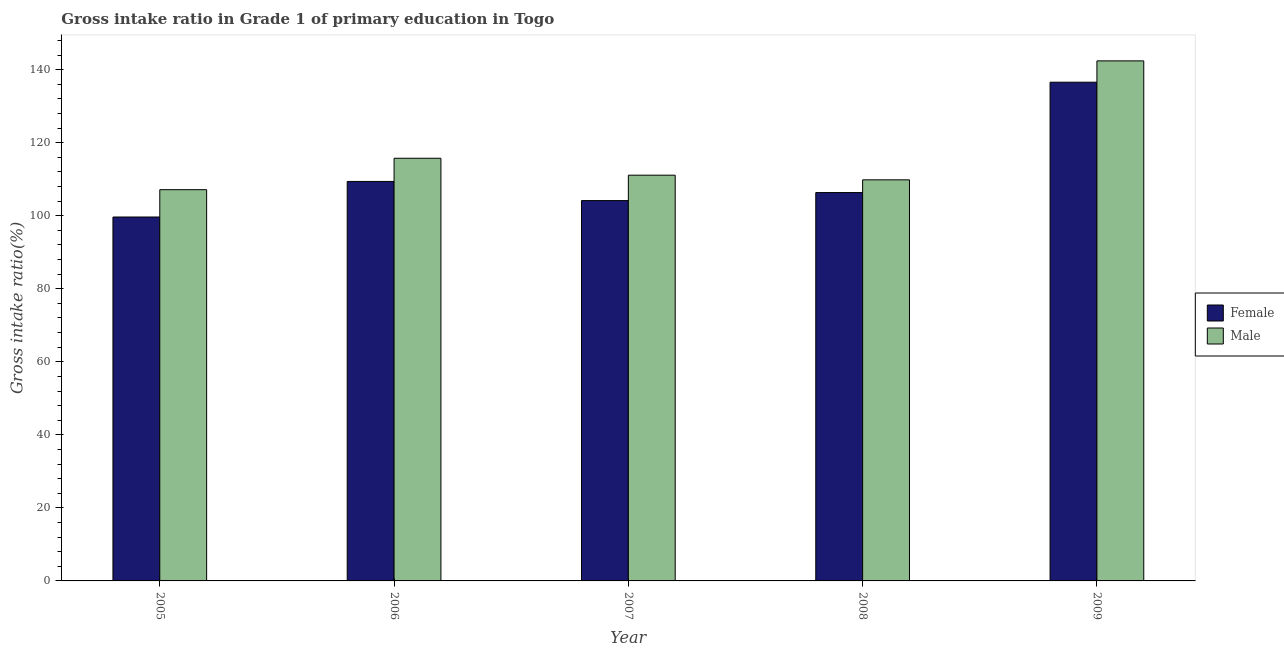How many groups of bars are there?
Make the answer very short. 5. How many bars are there on the 4th tick from the left?
Ensure brevity in your answer.  2. In how many cases, is the number of bars for a given year not equal to the number of legend labels?
Your response must be concise. 0. What is the gross intake ratio(male) in 2007?
Offer a terse response. 111.11. Across all years, what is the maximum gross intake ratio(female)?
Your answer should be very brief. 136.56. Across all years, what is the minimum gross intake ratio(female)?
Ensure brevity in your answer.  99.65. In which year was the gross intake ratio(female) minimum?
Provide a succinct answer. 2005. What is the total gross intake ratio(male) in the graph?
Give a very brief answer. 586.22. What is the difference between the gross intake ratio(male) in 2006 and that in 2007?
Give a very brief answer. 4.63. What is the difference between the gross intake ratio(female) in 2009 and the gross intake ratio(male) in 2006?
Offer a very short reply. 27.18. What is the average gross intake ratio(female) per year?
Offer a very short reply. 111.22. In how many years, is the gross intake ratio(male) greater than 96 %?
Ensure brevity in your answer.  5. What is the ratio of the gross intake ratio(female) in 2006 to that in 2007?
Provide a succinct answer. 1.05. Is the difference between the gross intake ratio(male) in 2007 and 2008 greater than the difference between the gross intake ratio(female) in 2007 and 2008?
Offer a very short reply. No. What is the difference between the highest and the second highest gross intake ratio(male)?
Your answer should be compact. 26.66. What is the difference between the highest and the lowest gross intake ratio(female)?
Your response must be concise. 36.91. Is the sum of the gross intake ratio(male) in 2007 and 2008 greater than the maximum gross intake ratio(female) across all years?
Ensure brevity in your answer.  Yes. What does the 1st bar from the left in 2009 represents?
Provide a short and direct response. Female. How many bars are there?
Offer a very short reply. 10. How many years are there in the graph?
Keep it short and to the point. 5. Does the graph contain any zero values?
Your answer should be compact. No. Does the graph contain grids?
Your answer should be very brief. No. Where does the legend appear in the graph?
Your answer should be very brief. Center right. How are the legend labels stacked?
Keep it short and to the point. Vertical. What is the title of the graph?
Provide a succinct answer. Gross intake ratio in Grade 1 of primary education in Togo. Does "Urban" appear as one of the legend labels in the graph?
Your response must be concise. No. What is the label or title of the Y-axis?
Provide a short and direct response. Gross intake ratio(%). What is the Gross intake ratio(%) in Female in 2005?
Keep it short and to the point. 99.65. What is the Gross intake ratio(%) in Male in 2005?
Provide a short and direct response. 107.14. What is the Gross intake ratio(%) in Female in 2006?
Provide a short and direct response. 109.39. What is the Gross intake ratio(%) of Male in 2006?
Your response must be concise. 115.74. What is the Gross intake ratio(%) in Female in 2007?
Offer a terse response. 104.15. What is the Gross intake ratio(%) in Male in 2007?
Make the answer very short. 111.11. What is the Gross intake ratio(%) of Female in 2008?
Your answer should be compact. 106.35. What is the Gross intake ratio(%) of Male in 2008?
Keep it short and to the point. 109.83. What is the Gross intake ratio(%) in Female in 2009?
Your answer should be very brief. 136.56. What is the Gross intake ratio(%) of Male in 2009?
Keep it short and to the point. 142.41. Across all years, what is the maximum Gross intake ratio(%) in Female?
Offer a terse response. 136.56. Across all years, what is the maximum Gross intake ratio(%) of Male?
Your answer should be compact. 142.41. Across all years, what is the minimum Gross intake ratio(%) in Female?
Provide a short and direct response. 99.65. Across all years, what is the minimum Gross intake ratio(%) in Male?
Ensure brevity in your answer.  107.14. What is the total Gross intake ratio(%) of Female in the graph?
Provide a short and direct response. 556.1. What is the total Gross intake ratio(%) of Male in the graph?
Give a very brief answer. 586.22. What is the difference between the Gross intake ratio(%) in Female in 2005 and that in 2006?
Your response must be concise. -9.73. What is the difference between the Gross intake ratio(%) of Male in 2005 and that in 2006?
Offer a very short reply. -8.61. What is the difference between the Gross intake ratio(%) in Female in 2005 and that in 2007?
Keep it short and to the point. -4.5. What is the difference between the Gross intake ratio(%) in Male in 2005 and that in 2007?
Give a very brief answer. -3.97. What is the difference between the Gross intake ratio(%) in Female in 2005 and that in 2008?
Provide a succinct answer. -6.69. What is the difference between the Gross intake ratio(%) in Male in 2005 and that in 2008?
Offer a very short reply. -2.69. What is the difference between the Gross intake ratio(%) of Female in 2005 and that in 2009?
Make the answer very short. -36.91. What is the difference between the Gross intake ratio(%) of Male in 2005 and that in 2009?
Provide a short and direct response. -35.27. What is the difference between the Gross intake ratio(%) of Female in 2006 and that in 2007?
Offer a terse response. 5.24. What is the difference between the Gross intake ratio(%) in Male in 2006 and that in 2007?
Your response must be concise. 4.63. What is the difference between the Gross intake ratio(%) in Female in 2006 and that in 2008?
Give a very brief answer. 3.04. What is the difference between the Gross intake ratio(%) in Male in 2006 and that in 2008?
Provide a succinct answer. 5.91. What is the difference between the Gross intake ratio(%) in Female in 2006 and that in 2009?
Your response must be concise. -27.18. What is the difference between the Gross intake ratio(%) of Male in 2006 and that in 2009?
Give a very brief answer. -26.66. What is the difference between the Gross intake ratio(%) of Female in 2007 and that in 2008?
Offer a terse response. -2.2. What is the difference between the Gross intake ratio(%) of Male in 2007 and that in 2008?
Your answer should be very brief. 1.28. What is the difference between the Gross intake ratio(%) of Female in 2007 and that in 2009?
Provide a short and direct response. -32.41. What is the difference between the Gross intake ratio(%) of Male in 2007 and that in 2009?
Provide a short and direct response. -31.3. What is the difference between the Gross intake ratio(%) in Female in 2008 and that in 2009?
Provide a short and direct response. -30.22. What is the difference between the Gross intake ratio(%) of Male in 2008 and that in 2009?
Provide a succinct answer. -32.58. What is the difference between the Gross intake ratio(%) in Female in 2005 and the Gross intake ratio(%) in Male in 2006?
Offer a terse response. -16.09. What is the difference between the Gross intake ratio(%) in Female in 2005 and the Gross intake ratio(%) in Male in 2007?
Offer a very short reply. -11.45. What is the difference between the Gross intake ratio(%) in Female in 2005 and the Gross intake ratio(%) in Male in 2008?
Give a very brief answer. -10.17. What is the difference between the Gross intake ratio(%) in Female in 2005 and the Gross intake ratio(%) in Male in 2009?
Make the answer very short. -42.75. What is the difference between the Gross intake ratio(%) of Female in 2006 and the Gross intake ratio(%) of Male in 2007?
Offer a terse response. -1.72. What is the difference between the Gross intake ratio(%) in Female in 2006 and the Gross intake ratio(%) in Male in 2008?
Make the answer very short. -0.44. What is the difference between the Gross intake ratio(%) of Female in 2006 and the Gross intake ratio(%) of Male in 2009?
Give a very brief answer. -33.02. What is the difference between the Gross intake ratio(%) in Female in 2007 and the Gross intake ratio(%) in Male in 2008?
Offer a terse response. -5.68. What is the difference between the Gross intake ratio(%) in Female in 2007 and the Gross intake ratio(%) in Male in 2009?
Give a very brief answer. -38.26. What is the difference between the Gross intake ratio(%) in Female in 2008 and the Gross intake ratio(%) in Male in 2009?
Your answer should be compact. -36.06. What is the average Gross intake ratio(%) of Female per year?
Ensure brevity in your answer.  111.22. What is the average Gross intake ratio(%) of Male per year?
Keep it short and to the point. 117.24. In the year 2005, what is the difference between the Gross intake ratio(%) of Female and Gross intake ratio(%) of Male?
Offer a very short reply. -7.48. In the year 2006, what is the difference between the Gross intake ratio(%) of Female and Gross intake ratio(%) of Male?
Offer a very short reply. -6.35. In the year 2007, what is the difference between the Gross intake ratio(%) of Female and Gross intake ratio(%) of Male?
Ensure brevity in your answer.  -6.96. In the year 2008, what is the difference between the Gross intake ratio(%) of Female and Gross intake ratio(%) of Male?
Your response must be concise. -3.48. In the year 2009, what is the difference between the Gross intake ratio(%) of Female and Gross intake ratio(%) of Male?
Offer a terse response. -5.84. What is the ratio of the Gross intake ratio(%) in Female in 2005 to that in 2006?
Offer a very short reply. 0.91. What is the ratio of the Gross intake ratio(%) of Male in 2005 to that in 2006?
Ensure brevity in your answer.  0.93. What is the ratio of the Gross intake ratio(%) in Female in 2005 to that in 2007?
Keep it short and to the point. 0.96. What is the ratio of the Gross intake ratio(%) of Male in 2005 to that in 2007?
Offer a very short reply. 0.96. What is the ratio of the Gross intake ratio(%) of Female in 2005 to that in 2008?
Your answer should be very brief. 0.94. What is the ratio of the Gross intake ratio(%) in Male in 2005 to that in 2008?
Provide a short and direct response. 0.98. What is the ratio of the Gross intake ratio(%) in Female in 2005 to that in 2009?
Offer a very short reply. 0.73. What is the ratio of the Gross intake ratio(%) in Male in 2005 to that in 2009?
Make the answer very short. 0.75. What is the ratio of the Gross intake ratio(%) in Female in 2006 to that in 2007?
Offer a terse response. 1.05. What is the ratio of the Gross intake ratio(%) in Male in 2006 to that in 2007?
Provide a succinct answer. 1.04. What is the ratio of the Gross intake ratio(%) of Female in 2006 to that in 2008?
Your answer should be very brief. 1.03. What is the ratio of the Gross intake ratio(%) of Male in 2006 to that in 2008?
Your response must be concise. 1.05. What is the ratio of the Gross intake ratio(%) in Female in 2006 to that in 2009?
Offer a very short reply. 0.8. What is the ratio of the Gross intake ratio(%) in Male in 2006 to that in 2009?
Make the answer very short. 0.81. What is the ratio of the Gross intake ratio(%) of Female in 2007 to that in 2008?
Offer a very short reply. 0.98. What is the ratio of the Gross intake ratio(%) of Male in 2007 to that in 2008?
Keep it short and to the point. 1.01. What is the ratio of the Gross intake ratio(%) in Female in 2007 to that in 2009?
Give a very brief answer. 0.76. What is the ratio of the Gross intake ratio(%) in Male in 2007 to that in 2009?
Give a very brief answer. 0.78. What is the ratio of the Gross intake ratio(%) of Female in 2008 to that in 2009?
Make the answer very short. 0.78. What is the ratio of the Gross intake ratio(%) of Male in 2008 to that in 2009?
Offer a terse response. 0.77. What is the difference between the highest and the second highest Gross intake ratio(%) in Female?
Ensure brevity in your answer.  27.18. What is the difference between the highest and the second highest Gross intake ratio(%) of Male?
Your answer should be compact. 26.66. What is the difference between the highest and the lowest Gross intake ratio(%) of Female?
Keep it short and to the point. 36.91. What is the difference between the highest and the lowest Gross intake ratio(%) of Male?
Offer a very short reply. 35.27. 